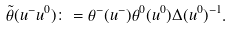<formula> <loc_0><loc_0><loc_500><loc_500>\tilde { \theta } ( u ^ { - } u ^ { 0 } ) \colon = \theta ^ { - } ( u ^ { - } ) \theta ^ { 0 } ( u ^ { 0 } ) \Delta ( u ^ { 0 } ) ^ { - 1 } .</formula> 